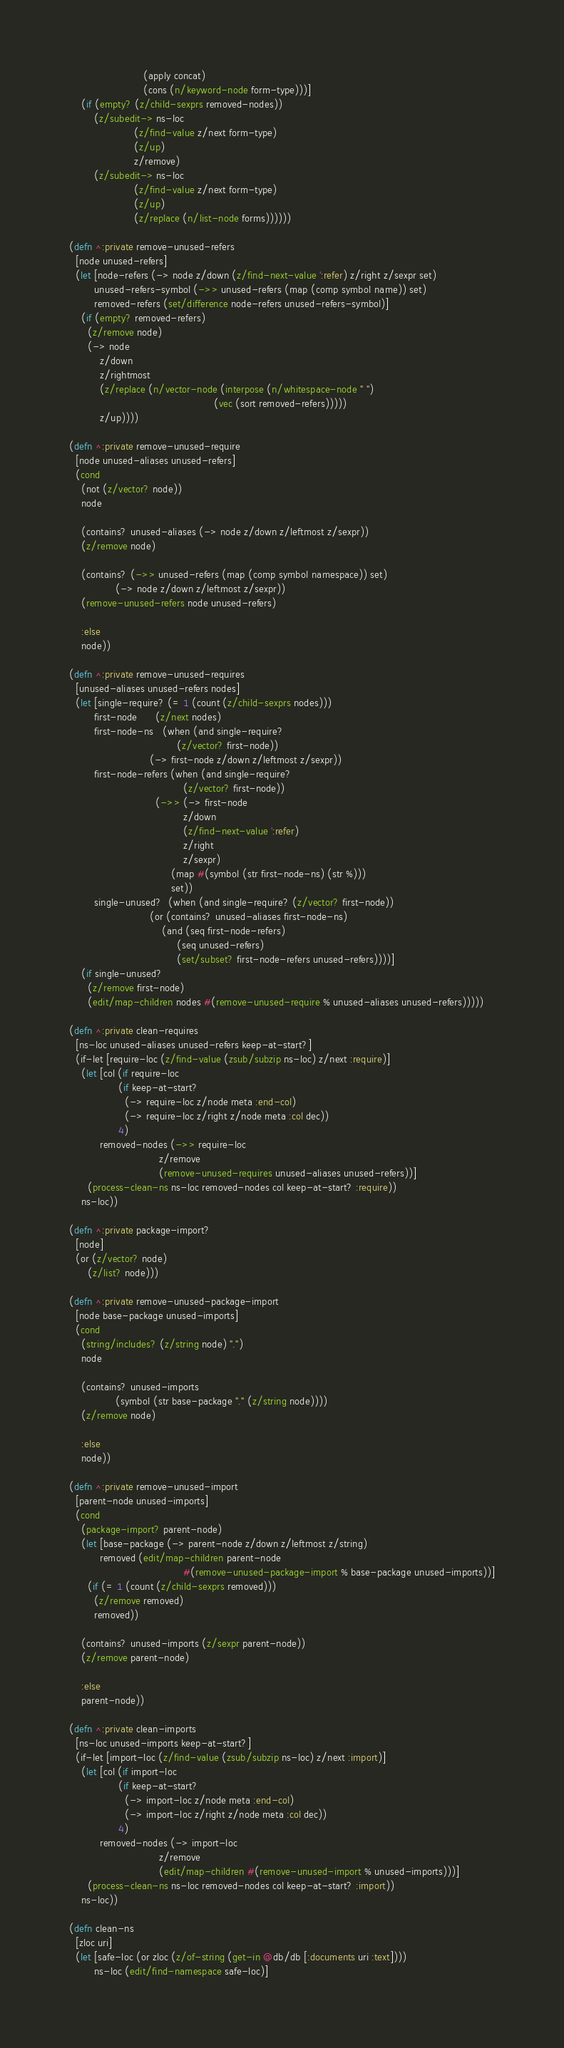Convert code to text. <code><loc_0><loc_0><loc_500><loc_500><_Clojure_>                        (apply concat)
                        (cons (n/keyword-node form-type)))]
    (if (empty? (z/child-sexprs removed-nodes))
        (z/subedit-> ns-loc
                     (z/find-value z/next form-type)
                     (z/up)
                     z/remove)
        (z/subedit-> ns-loc
                     (z/find-value z/next form-type)
                     (z/up)
                     (z/replace (n/list-node forms))))))

(defn ^:private remove-unused-refers
  [node unused-refers]
  (let [node-refers (-> node z/down (z/find-next-value ':refer) z/right z/sexpr set)
        unused-refers-symbol (->> unused-refers (map (comp symbol name)) set)
        removed-refers (set/difference node-refers unused-refers-symbol)]
    (if (empty? removed-refers)
      (z/remove node)
      (-> node
          z/down
          z/rightmost
          (z/replace (n/vector-node (interpose (n/whitespace-node " ")
                                               (vec (sort removed-refers)))))
          z/up))))

(defn ^:private remove-unused-require
  [node unused-aliases unused-refers]
  (cond
    (not (z/vector? node))
    node

    (contains? unused-aliases (-> node z/down z/leftmost z/sexpr))
    (z/remove node)

    (contains? (->> unused-refers (map (comp symbol namespace)) set)
               (-> node z/down z/leftmost z/sexpr))
    (remove-unused-refers node unused-refers)

    :else
    node))

(defn ^:private remove-unused-requires
  [unused-aliases unused-refers nodes]
  (let [single-require? (= 1 (count (z/child-sexprs nodes)))
        first-node      (z/next nodes)
        first-node-ns   (when (and single-require?
                                   (z/vector? first-node))
                          (-> first-node z/down z/leftmost z/sexpr))
        first-node-refers (when (and single-require?
                                     (z/vector? first-node))
                            (->> (-> first-node
                                     z/down
                                     (z/find-next-value ':refer)
                                     z/right
                                     z/sexpr)
                                 (map #(symbol (str first-node-ns) (str %)))
                                 set))
        single-unused?  (when (and single-require? (z/vector? first-node))
                          (or (contains? unused-aliases first-node-ns)
                              (and (seq first-node-refers)
                                   (seq unused-refers)
                                   (set/subset? first-node-refers unused-refers))))]
    (if single-unused?
      (z/remove first-node)
      (edit/map-children nodes #(remove-unused-require % unused-aliases unused-refers)))))

(defn ^:private clean-requires
  [ns-loc unused-aliases unused-refers keep-at-start?]
  (if-let [require-loc (z/find-value (zsub/subzip ns-loc) z/next :require)]
    (let [col (if require-loc
                (if keep-at-start?
                  (-> require-loc z/node meta :end-col)
                  (-> require-loc z/right z/node meta :col dec))
                4)
          removed-nodes (->> require-loc
                             z/remove
                             (remove-unused-requires unused-aliases unused-refers))]
      (process-clean-ns ns-loc removed-nodes col keep-at-start? :require))
    ns-loc))

(defn ^:private package-import?
  [node]
  (or (z/vector? node)
      (z/list? node)))

(defn ^:private remove-unused-package-import
  [node base-package unused-imports]
  (cond
    (string/includes? (z/string node) ".")
    node

    (contains? unused-imports
               (symbol (str base-package "." (z/string node))))
    (z/remove node)

    :else
    node))

(defn ^:private remove-unused-import
  [parent-node unused-imports]
  (cond
    (package-import? parent-node)
    (let [base-package (-> parent-node z/down z/leftmost z/string)
          removed (edit/map-children parent-node
                                     #(remove-unused-package-import % base-package unused-imports))]
      (if (= 1 (count (z/child-sexprs removed)))
        (z/remove removed)
        removed))

    (contains? unused-imports (z/sexpr parent-node))
    (z/remove parent-node)

    :else
    parent-node))

(defn ^:private clean-imports
  [ns-loc unused-imports keep-at-start?]
  (if-let [import-loc (z/find-value (zsub/subzip ns-loc) z/next :import)]
    (let [col (if import-loc
                (if keep-at-start?
                  (-> import-loc z/node meta :end-col)
                  (-> import-loc z/right z/node meta :col dec))
                4)
          removed-nodes (-> import-loc
                             z/remove
                             (edit/map-children #(remove-unused-import % unused-imports)))]
      (process-clean-ns ns-loc removed-nodes col keep-at-start? :import))
    ns-loc))

(defn clean-ns
  [zloc uri]
  (let [safe-loc (or zloc (z/of-string (get-in @db/db [:documents uri :text])))
        ns-loc (edit/find-namespace safe-loc)]</code> 